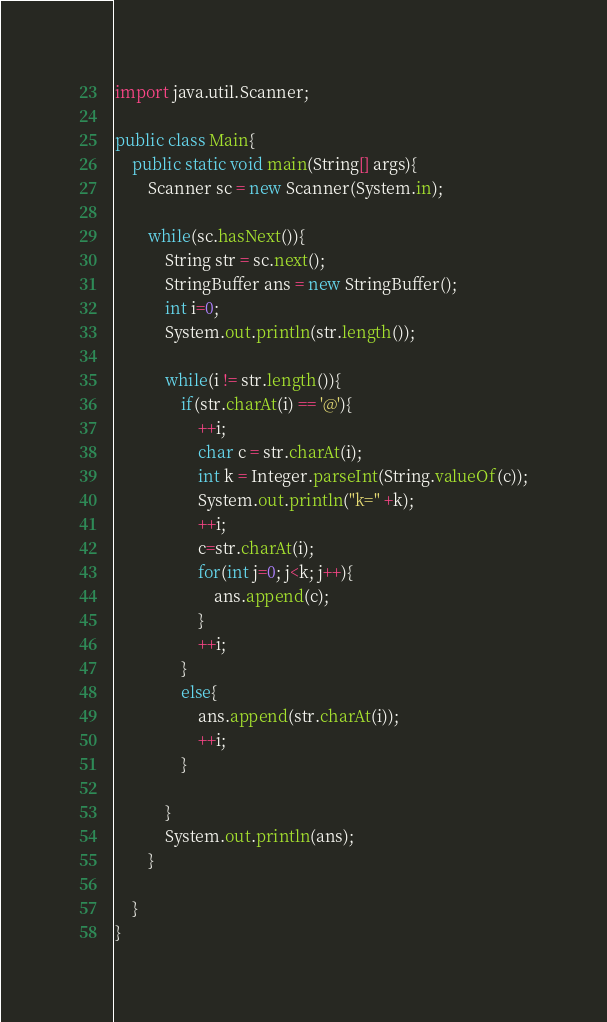<code> <loc_0><loc_0><loc_500><loc_500><_Java_>import java.util.Scanner;

public class Main{
	public static void main(String[] args){
		Scanner sc = new Scanner(System.in);
		
		while(sc.hasNext()){
			String str = sc.next();
			StringBuffer ans = new StringBuffer();
			int i=0;
			System.out.println(str.length());
			
			while(i != str.length()){
				if(str.charAt(i) == '@'){
					++i;		
					char c = str.charAt(i);
					int k = Integer.parseInt(String.valueOf(c));
					System.out.println("k=" +k);
					++i;
					c=str.charAt(i);	
					for(int j=0; j<k; j++){
						ans.append(c);
					}
					++i;
				}
				else{
					ans.append(str.charAt(i));
					++i;
				}
			
			}
			System.out.println(ans);	
		}
	
	}
}</code> 